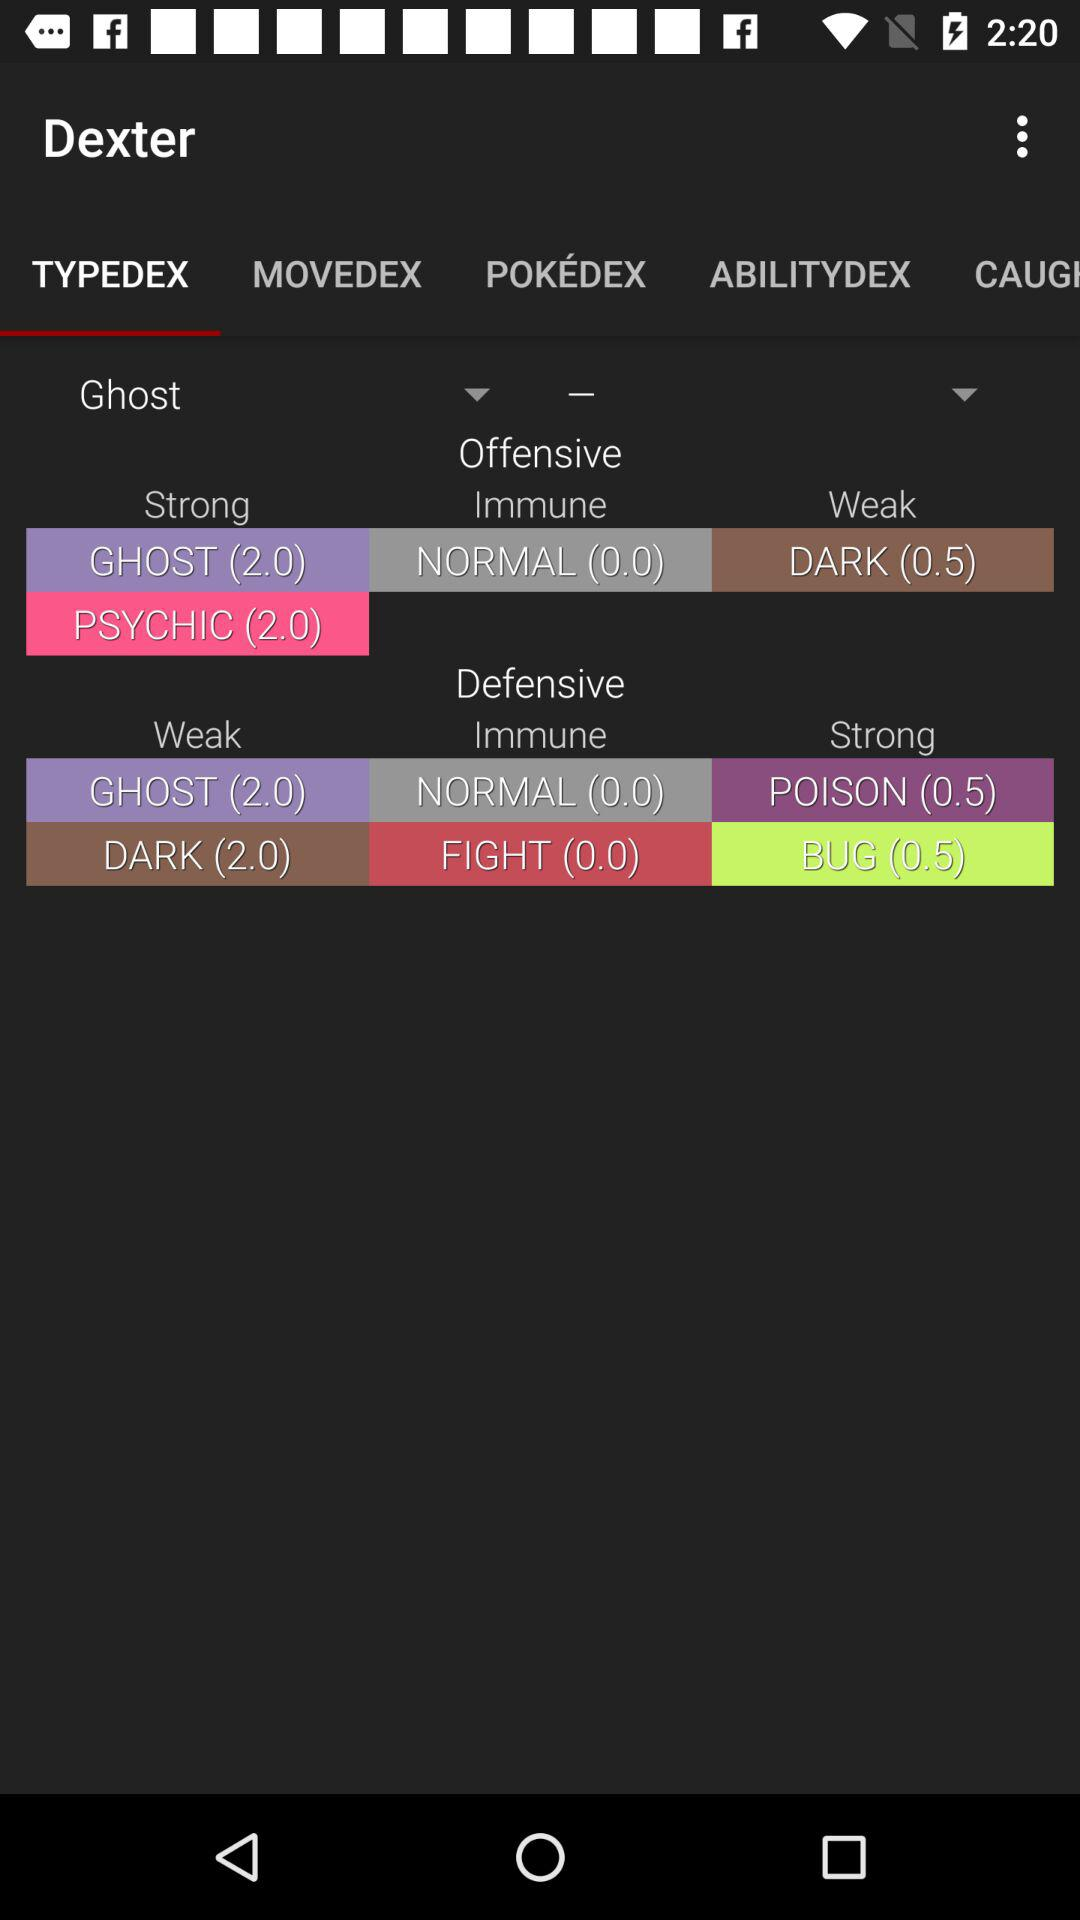How many types does Ghost resist?
Answer the question using a single word or phrase. 2 